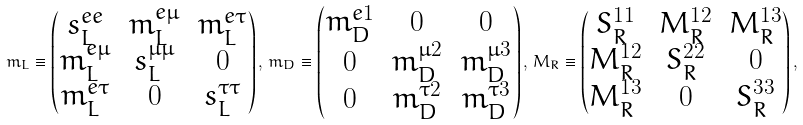Convert formula to latex. <formula><loc_0><loc_0><loc_500><loc_500>m _ { L } \equiv \begin{pmatrix} s ^ { e e } _ { L } & m ^ { e \mu } _ { L } & m ^ { e \tau } _ { L } \\ m ^ { e \mu } _ { L } & s ^ { \mu \mu } _ { L } & 0 \\ m ^ { e \tau } _ { L } & 0 & s ^ { \tau \tau } _ { L } \end{pmatrix} , \, m _ { D } \equiv \begin{pmatrix} m ^ { e 1 } _ { D } & 0 & 0 \\ 0 & m ^ { \mu 2 } _ { D } & m ^ { \mu 3 } _ { D } \\ 0 & m ^ { \tau 2 } _ { D } & m ^ { \tau 3 } _ { D } \end{pmatrix} , \, M _ { R } \equiv \begin{pmatrix} S ^ { 1 1 } _ { R } & M ^ { 1 2 } _ { R } & M ^ { 1 3 } _ { R } \\ M ^ { 1 2 } _ { R } & S ^ { 2 2 } _ { R } & 0 \\ M ^ { 1 3 } _ { R } & 0 & S ^ { 3 3 } _ { R } \end{pmatrix} ,</formula> 